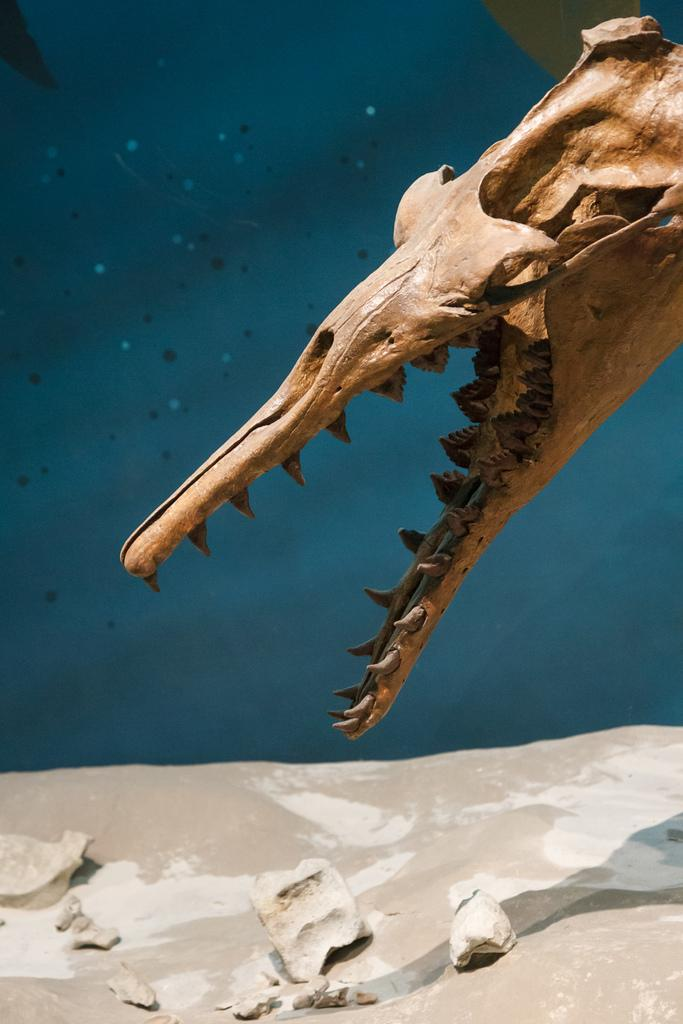What is the main subject of the image? There is a skull of an animal in the image. What color is the background in the image? There is a blue background in the image. What color is the surface at the bottom of the image? There is a white surface at the bottom of the image. How many books can be seen on the white surface in the image? There are no books present in the image; it only features a skull of an animal against a blue background with a white surface at the bottom. 